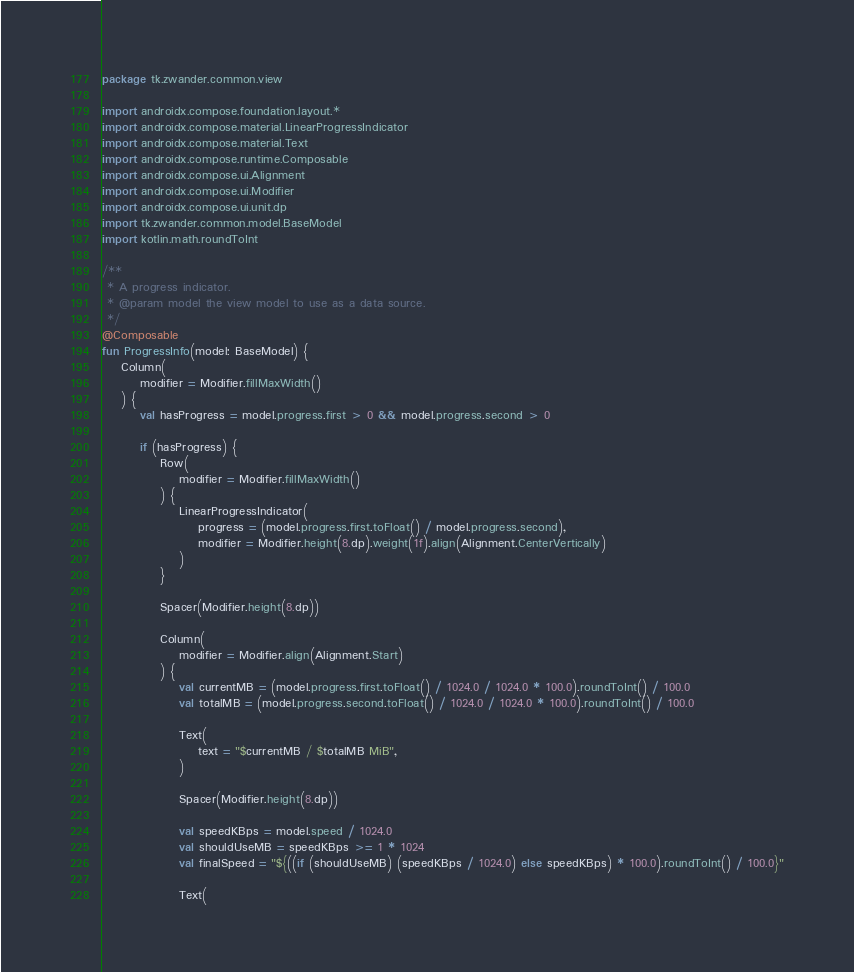<code> <loc_0><loc_0><loc_500><loc_500><_Kotlin_>package tk.zwander.common.view

import androidx.compose.foundation.layout.*
import androidx.compose.material.LinearProgressIndicator
import androidx.compose.material.Text
import androidx.compose.runtime.Composable
import androidx.compose.ui.Alignment
import androidx.compose.ui.Modifier
import androidx.compose.ui.unit.dp
import tk.zwander.common.model.BaseModel
import kotlin.math.roundToInt

/**
 * A progress indicator.
 * @param model the view model to use as a data source.
 */
@Composable
fun ProgressInfo(model: BaseModel) {
    Column(
        modifier = Modifier.fillMaxWidth()
    ) {
        val hasProgress = model.progress.first > 0 && model.progress.second > 0

        if (hasProgress) {
            Row(
                modifier = Modifier.fillMaxWidth()
            ) {
                LinearProgressIndicator(
                    progress = (model.progress.first.toFloat() / model.progress.second),
                    modifier = Modifier.height(8.dp).weight(1f).align(Alignment.CenterVertically)
                )
            }

            Spacer(Modifier.height(8.dp))

            Column(
                modifier = Modifier.align(Alignment.Start)
            ) {
                val currentMB = (model.progress.first.toFloat() / 1024.0 / 1024.0 * 100.0).roundToInt() / 100.0
                val totalMB = (model.progress.second.toFloat() / 1024.0 / 1024.0 * 100.0).roundToInt() / 100.0

                Text(
                    text = "$currentMB / $totalMB MiB",
                )

                Spacer(Modifier.height(8.dp))

                val speedKBps = model.speed / 1024.0
                val shouldUseMB = speedKBps >= 1 * 1024
                val finalSpeed = "${((if (shouldUseMB) (speedKBps / 1024.0) else speedKBps) * 100.0).roundToInt() / 100.0}"

                Text(</code> 